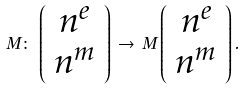<formula> <loc_0><loc_0><loc_500><loc_500>M \colon \, \left ( \begin{array} { c } n ^ { e } \\ n ^ { m } \end{array} \right ) \, \rightarrow \, M \left ( \begin{array} { c } n ^ { e } \\ n ^ { m } \end{array} \right ) .</formula> 